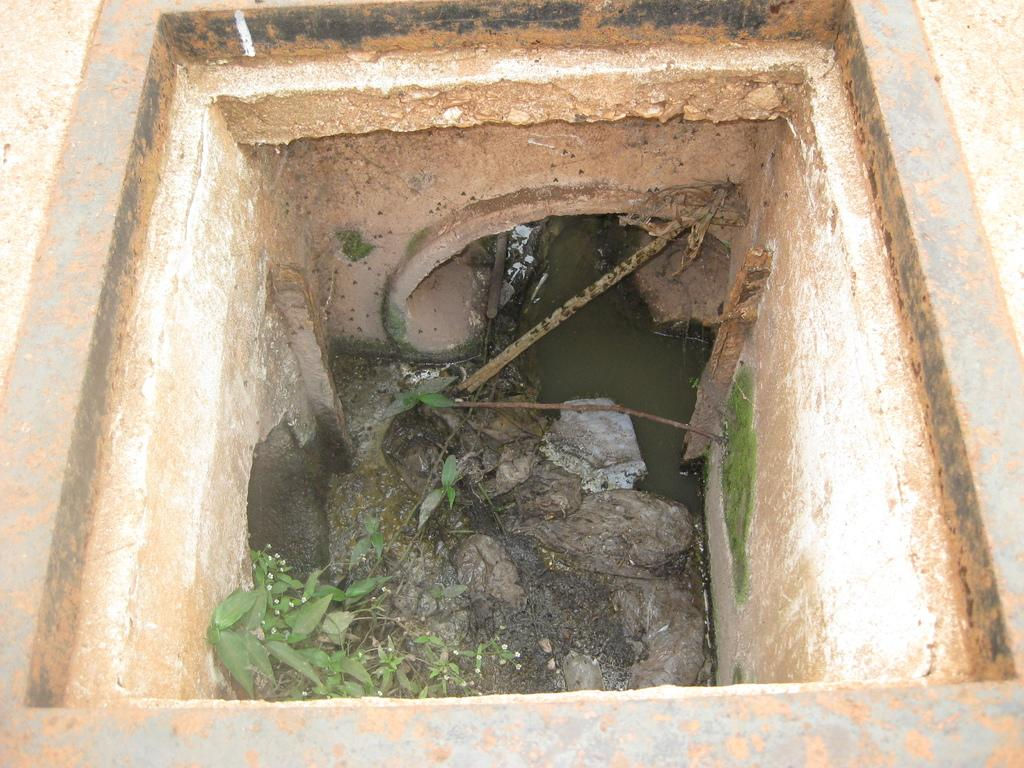What is the main feature of the image? The main feature of the image is a drainage pit. What can be found in the center of the drainage pit? There are leaves and a pipe in the center of the drainage pit. What is the purpose of the drainage pit? The drainage pit is used to collect wastewater. What material is the top of the drainage pit made of? The top of the drainage pit is made of cement road. What other object is present in the image? There is an iron frame in the image. How many eyes can be seen on the hill in the image? There is no hill or eyes present in the image. Can you tell me how to pull the drainage pit out of the ground in the image? The drainage pit is not a removable object, and it is not possible to pull it out of the ground in the image. 